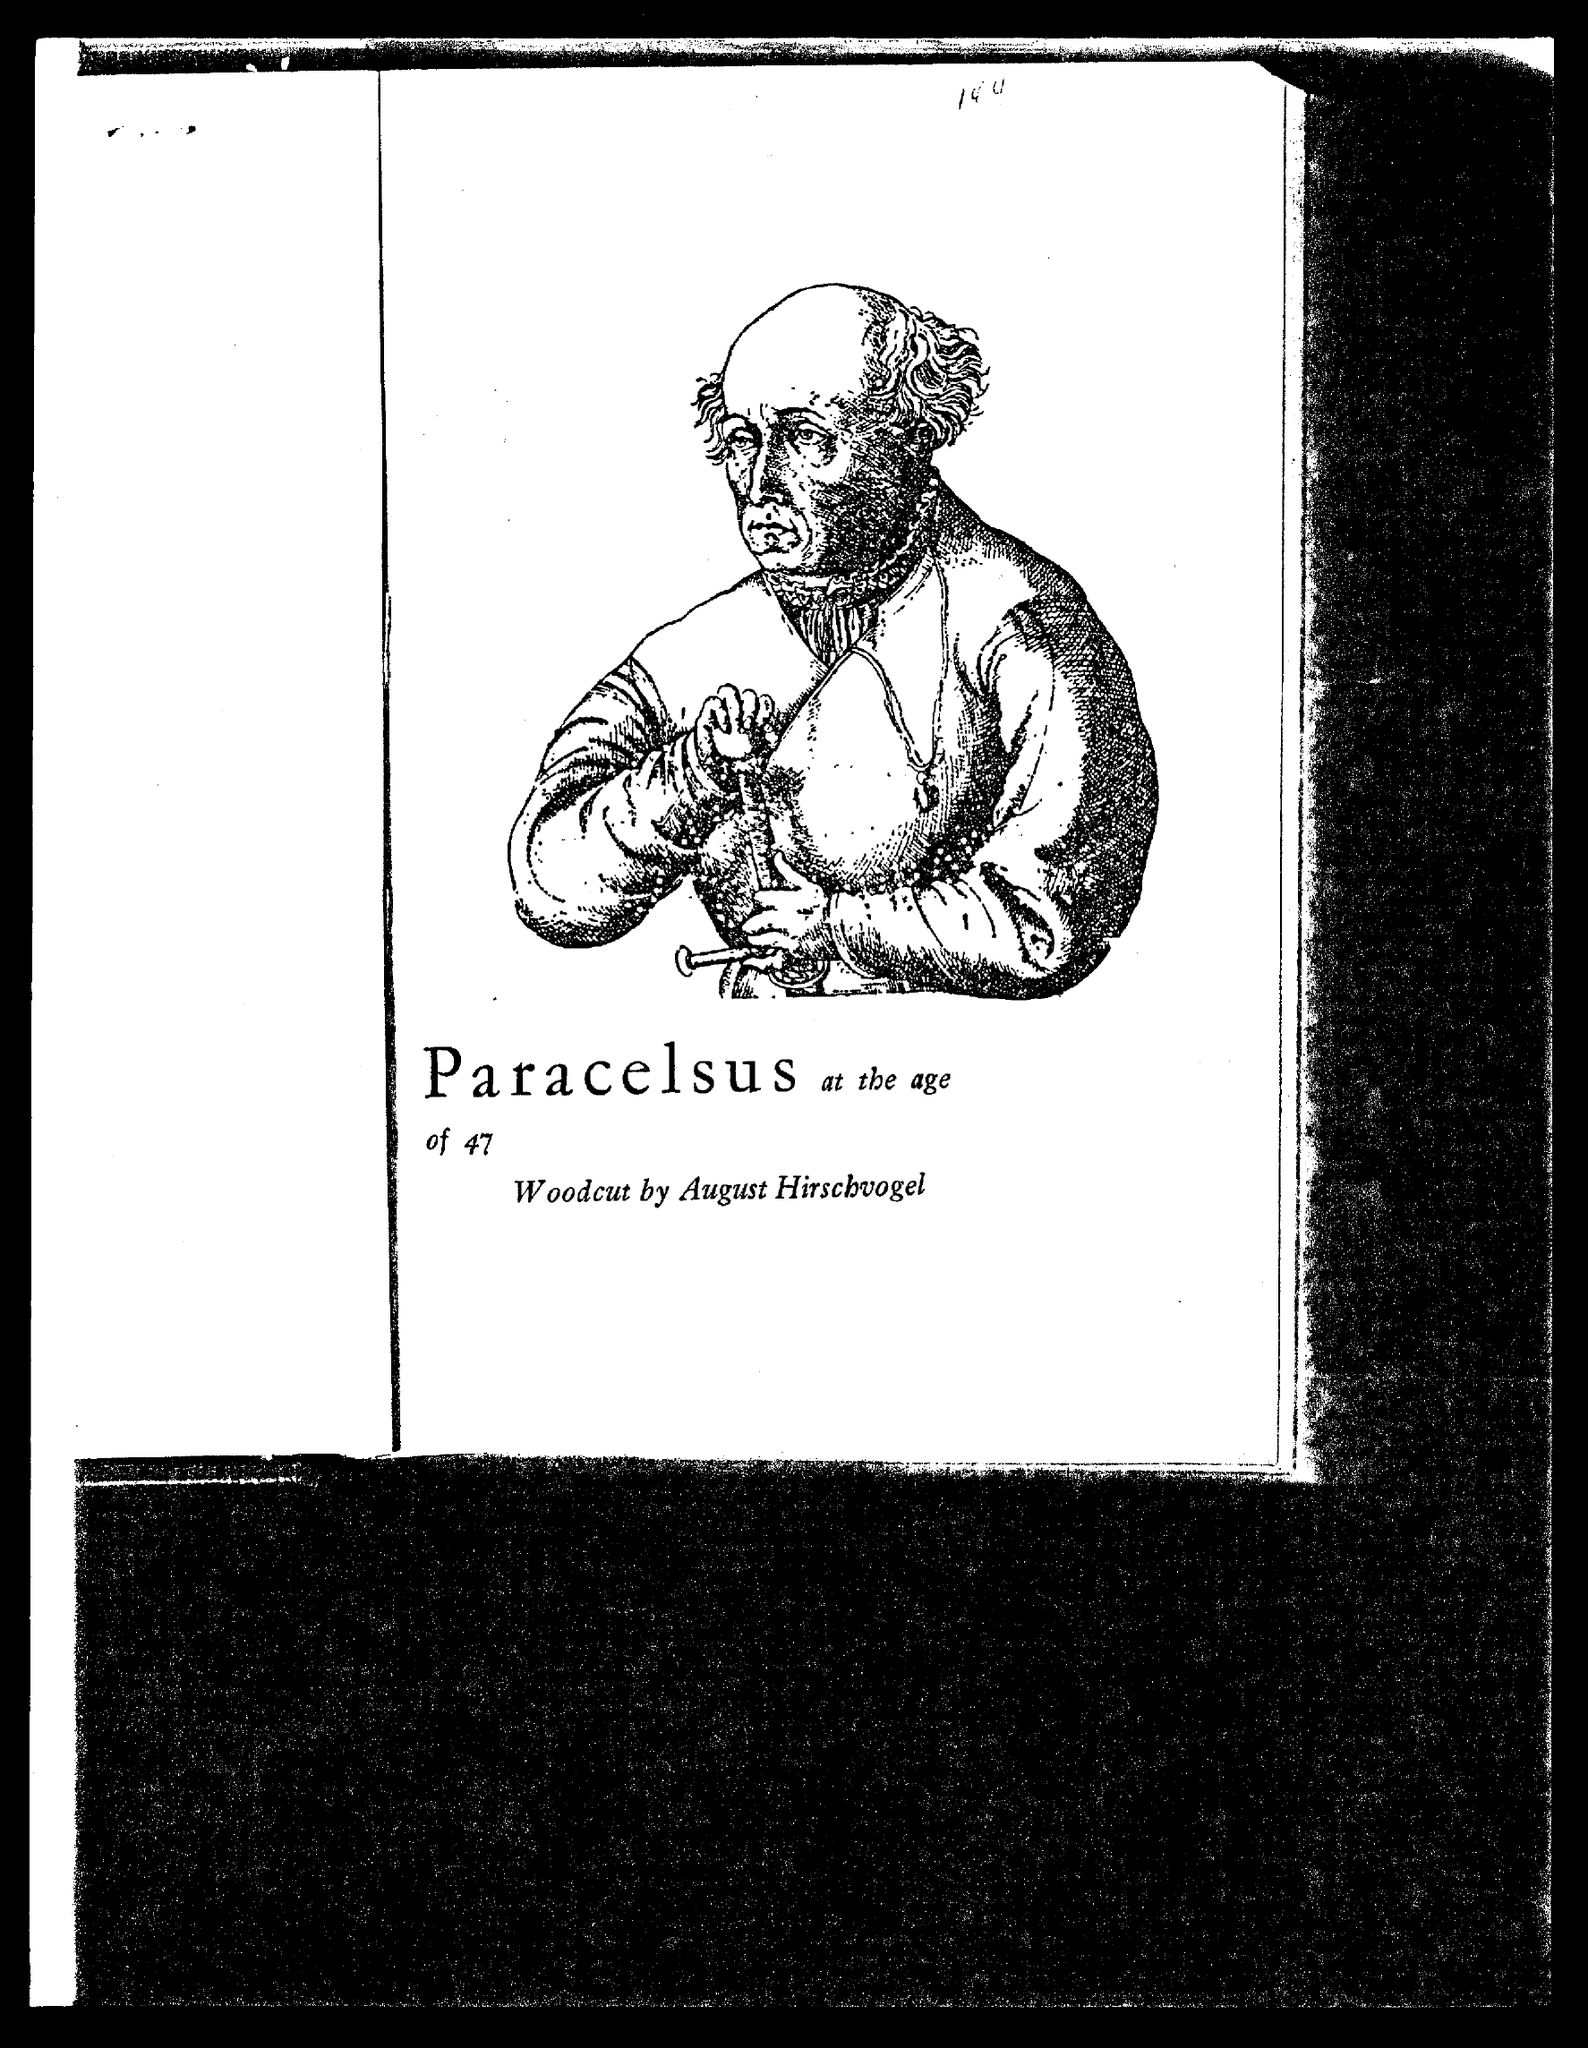Who is the person in the picture?
Your answer should be very brief. Paracelsus. What is the age of paracelsus in the picture?
Ensure brevity in your answer.  47. 